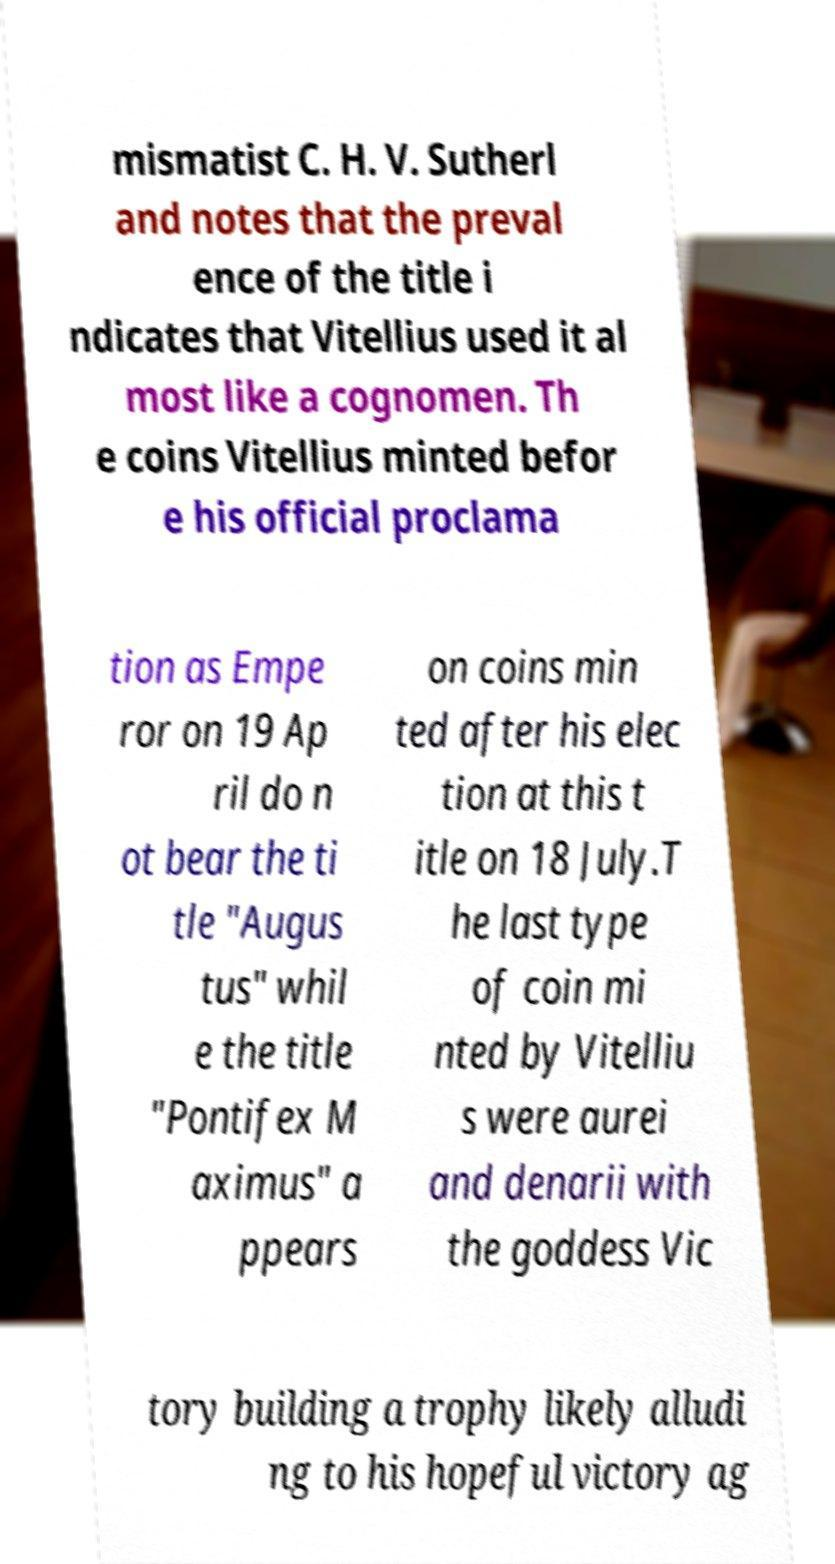Can you read and provide the text displayed in the image?This photo seems to have some interesting text. Can you extract and type it out for me? mismatist C. H. V. Sutherl and notes that the preval ence of the title i ndicates that Vitellius used it al most like a cognomen. Th e coins Vitellius minted befor e his official proclama tion as Empe ror on 19 Ap ril do n ot bear the ti tle "Augus tus" whil e the title "Pontifex M aximus" a ppears on coins min ted after his elec tion at this t itle on 18 July.T he last type of coin mi nted by Vitelliu s were aurei and denarii with the goddess Vic tory building a trophy likely alludi ng to his hopeful victory ag 